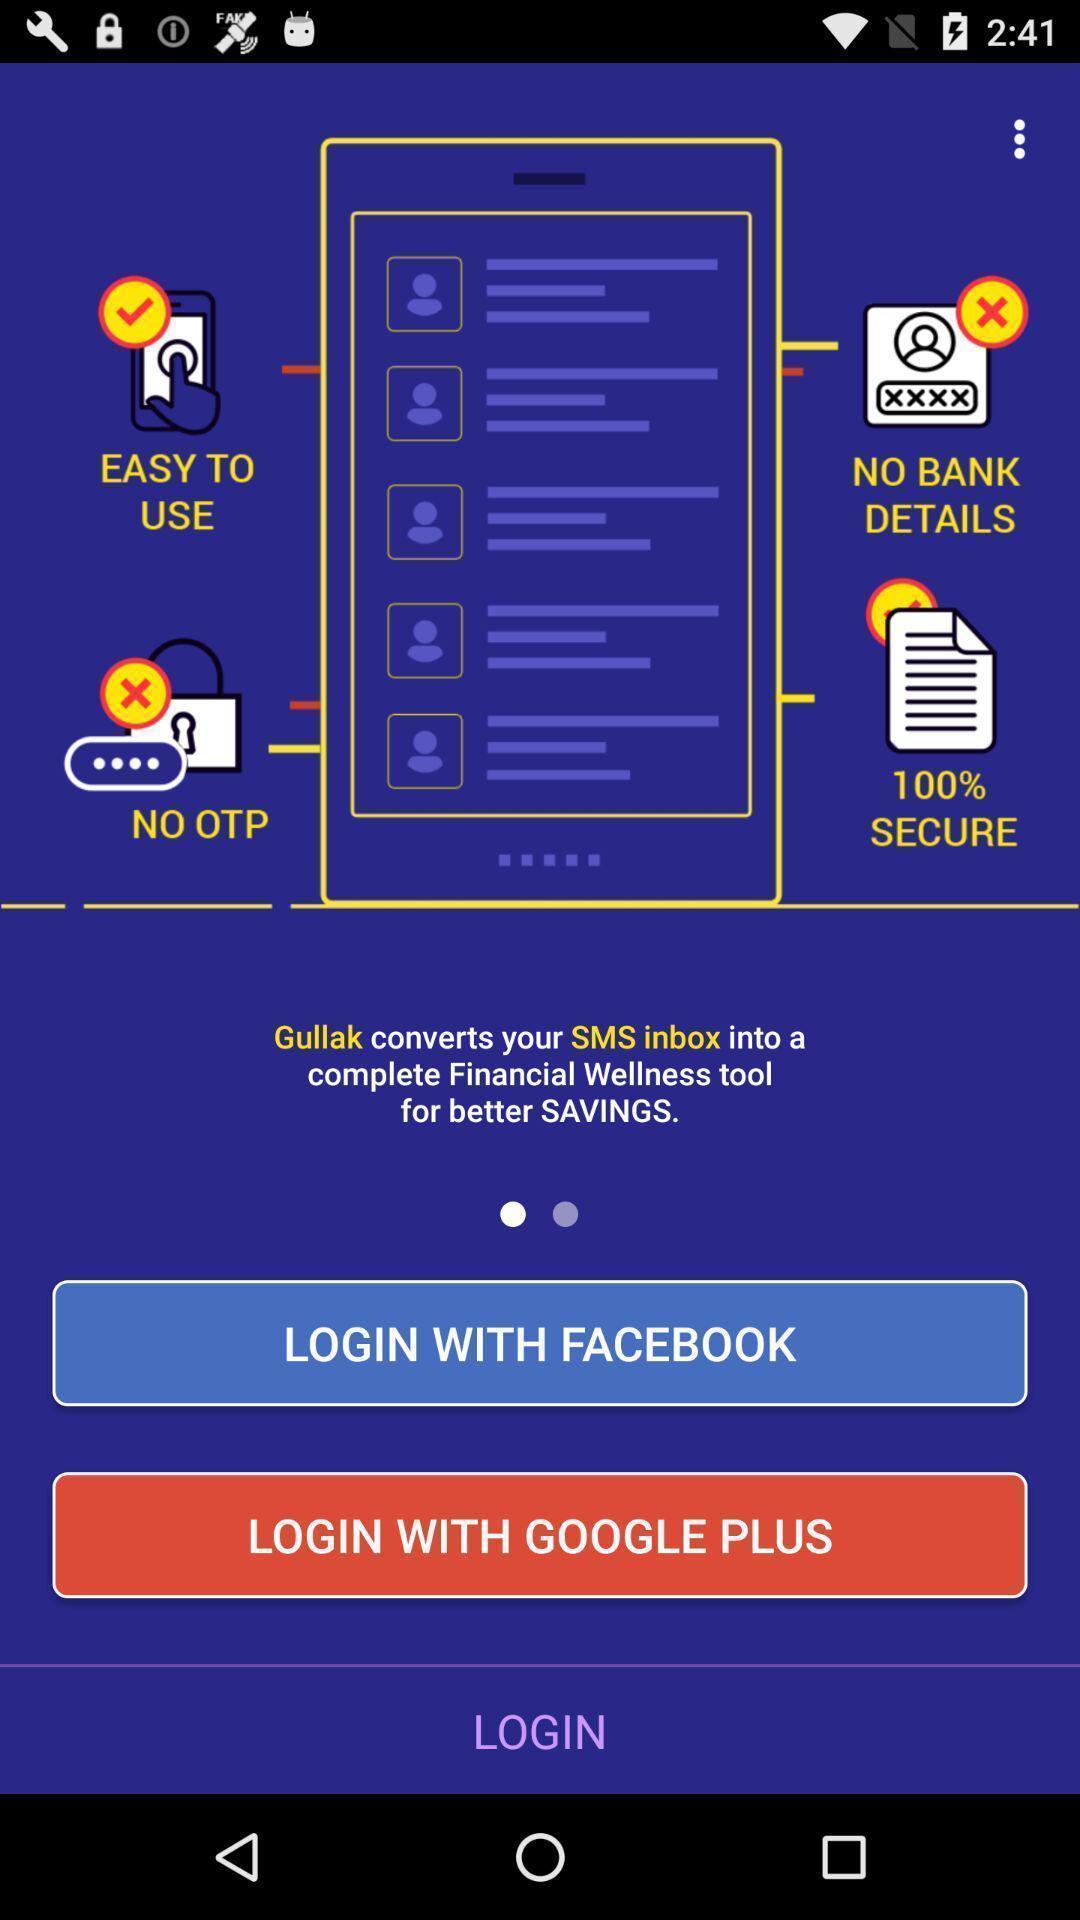Give me a narrative description of this picture. Screen displaying log in page. 